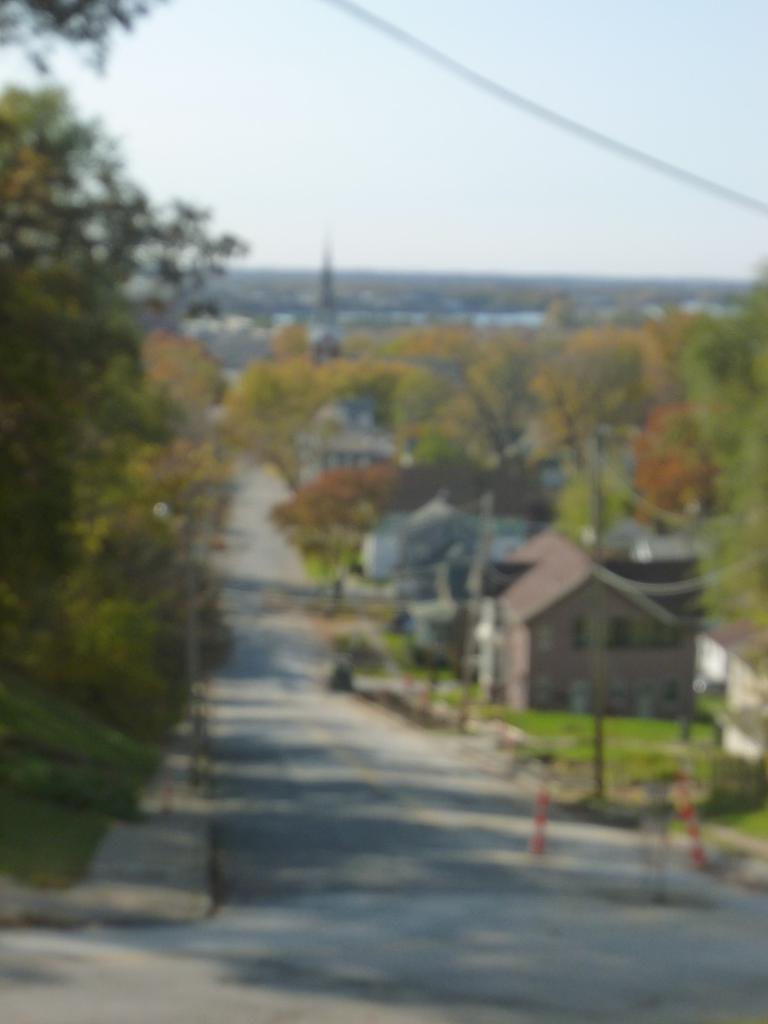What type of structure is present in the image? There is a building in the image. What other natural elements can be seen in the image? There are trees in the image. Where is the grass located in the image? The grass is visible at the right bottom of the image. What is visible at the top of the image? The sky is visible at the top of the image. How many chickens are roaming around the building in the image? There are no chickens present in the image. What type of machine is visible near the trees in the image? There is no machine visible in the image; only the building, trees, grass, and sky are present. 